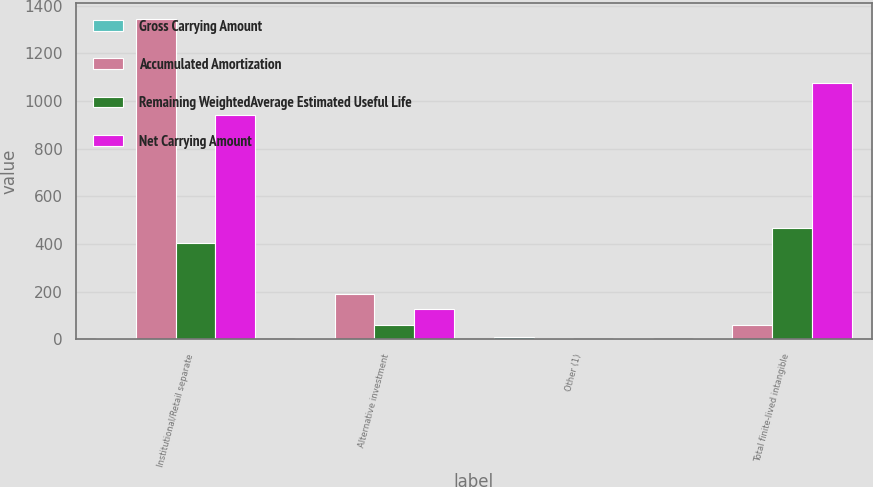Convert chart. <chart><loc_0><loc_0><loc_500><loc_500><stacked_bar_chart><ecel><fcel>Institutional/Retail separate<fcel>Alternative investment<fcel>Other (1)<fcel>Total finite-lived intangible<nl><fcel>Gross Carrying Amount<fcel>7.4<fcel>5.1<fcel>8.6<fcel>7.2<nl><fcel>Accumulated Amortization<fcel>1345<fcel>190<fcel>6<fcel>62<nl><fcel>Remaining WeightedAverage Estimated Useful Life<fcel>403<fcel>62<fcel>1<fcel>466<nl><fcel>Net Carrying Amount<fcel>942<fcel>128<fcel>5<fcel>1075<nl></chart> 